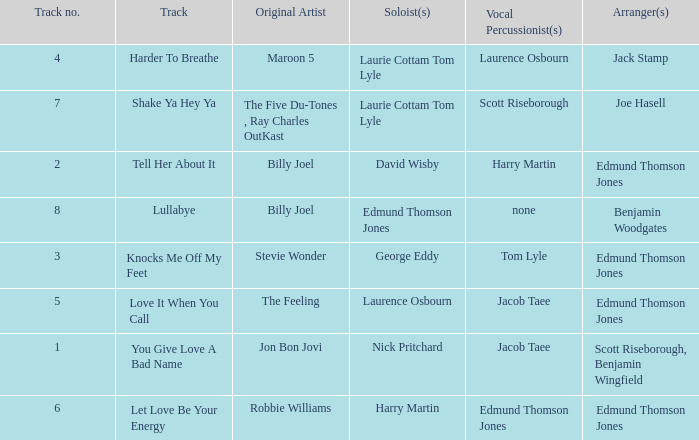Who arranged song(s) with tom lyle on the vocal percussion? Edmund Thomson Jones. 